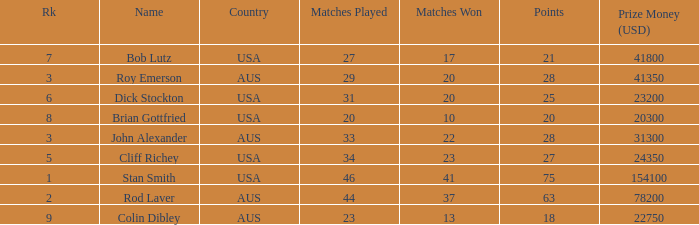How much prize money (in usd) did bob lutz win 41800.0. 